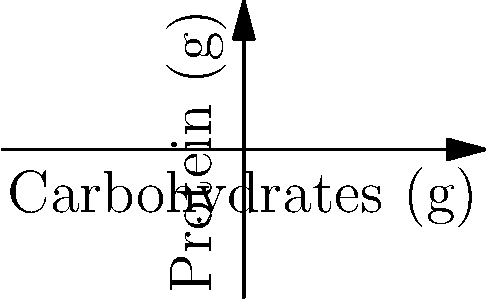Two meal plans are represented on a coordinate system where the x-axis shows carbohydrate content (in grams) and the y-axis shows protein content (in grams). Meal Plan 1 is represented by points A(50,30) and B(60,25), while Meal Plan 2 is represented by points C(70,35) and D(80,40). Which meal plan offers a more balanced nutritional profile in terms of carbohydrate and protein variation? Use the distance formula to justify your answer. To determine which meal plan offers a more balanced nutritional profile, we need to calculate the distance between the points representing each meal plan using the distance formula:

$d = \sqrt{(x_2-x_1)^2 + (y_2-y_1)^2}$

For Meal Plan 1 (points A and B):
$d_1 = \sqrt{(60-50)^2 + (25-30)^2}$
$d_1 = \sqrt{10^2 + (-5)^2}$
$d_1 = \sqrt{100 + 25} = \sqrt{125} \approx 11.18$

For Meal Plan 2 (points C and D):
$d_2 = \sqrt{(80-70)^2 + (40-35)^2}$
$d_2 = \sqrt{10^2 + 5^2}$
$d_2 = \sqrt{100 + 25} = \sqrt{125} \approx 11.18$

Both meal plans have the same distance between their respective points, indicating equal variation in nutritional content. However, Meal Plan 2 offers higher overall protein and carbohydrate content, which is generally more suitable for a young forward with high energy requirements.

Therefore, Meal Plan 2 (represented by points C and D) offers a more balanced and appropriate nutritional profile for the given persona.
Answer: Meal Plan 2 